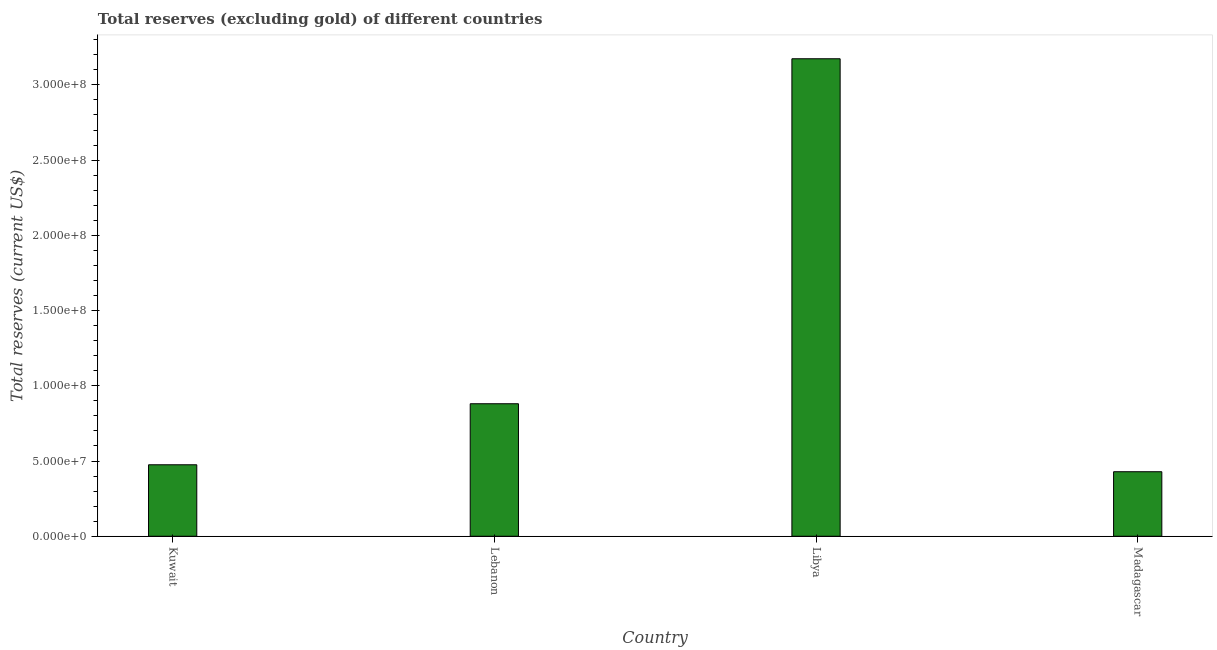Does the graph contain any zero values?
Give a very brief answer. No. What is the title of the graph?
Offer a very short reply. Total reserves (excluding gold) of different countries. What is the label or title of the Y-axis?
Your response must be concise. Total reserves (current US$). What is the total reserves (excluding gold) in Madagascar?
Offer a terse response. 4.29e+07. Across all countries, what is the maximum total reserves (excluding gold)?
Your answer should be very brief. 3.17e+08. Across all countries, what is the minimum total reserves (excluding gold)?
Offer a terse response. 4.29e+07. In which country was the total reserves (excluding gold) maximum?
Your answer should be compact. Libya. In which country was the total reserves (excluding gold) minimum?
Keep it short and to the point. Madagascar. What is the sum of the total reserves (excluding gold)?
Provide a short and direct response. 4.96e+08. What is the difference between the total reserves (excluding gold) in Lebanon and Libya?
Provide a succinct answer. -2.29e+08. What is the average total reserves (excluding gold) per country?
Keep it short and to the point. 1.24e+08. What is the median total reserves (excluding gold)?
Give a very brief answer. 6.78e+07. In how many countries, is the total reserves (excluding gold) greater than 240000000 US$?
Keep it short and to the point. 1. What is the ratio of the total reserves (excluding gold) in Kuwait to that in Lebanon?
Keep it short and to the point. 0.54. What is the difference between the highest and the second highest total reserves (excluding gold)?
Ensure brevity in your answer.  2.29e+08. What is the difference between the highest and the lowest total reserves (excluding gold)?
Offer a terse response. 2.74e+08. In how many countries, is the total reserves (excluding gold) greater than the average total reserves (excluding gold) taken over all countries?
Offer a very short reply. 1. How many bars are there?
Offer a terse response. 4. Are all the bars in the graph horizontal?
Ensure brevity in your answer.  No. How many countries are there in the graph?
Your answer should be compact. 4. Are the values on the major ticks of Y-axis written in scientific E-notation?
Your answer should be very brief. Yes. What is the Total reserves (current US$) of Kuwait?
Offer a terse response. 4.75e+07. What is the Total reserves (current US$) in Lebanon?
Give a very brief answer. 8.81e+07. What is the Total reserves (current US$) of Libya?
Your response must be concise. 3.17e+08. What is the Total reserves (current US$) of Madagascar?
Provide a succinct answer. 4.29e+07. What is the difference between the Total reserves (current US$) in Kuwait and Lebanon?
Offer a terse response. -4.06e+07. What is the difference between the Total reserves (current US$) in Kuwait and Libya?
Ensure brevity in your answer.  -2.70e+08. What is the difference between the Total reserves (current US$) in Kuwait and Madagascar?
Offer a terse response. 4.63e+06. What is the difference between the Total reserves (current US$) in Lebanon and Libya?
Offer a terse response. -2.29e+08. What is the difference between the Total reserves (current US$) in Lebanon and Madagascar?
Your answer should be compact. 4.52e+07. What is the difference between the Total reserves (current US$) in Libya and Madagascar?
Give a very brief answer. 2.74e+08. What is the ratio of the Total reserves (current US$) in Kuwait to that in Lebanon?
Your answer should be very brief. 0.54. What is the ratio of the Total reserves (current US$) in Kuwait to that in Libya?
Your response must be concise. 0.15. What is the ratio of the Total reserves (current US$) in Kuwait to that in Madagascar?
Give a very brief answer. 1.11. What is the ratio of the Total reserves (current US$) in Lebanon to that in Libya?
Offer a very short reply. 0.28. What is the ratio of the Total reserves (current US$) in Lebanon to that in Madagascar?
Give a very brief answer. 2.05. What is the ratio of the Total reserves (current US$) in Libya to that in Madagascar?
Offer a terse response. 7.4. 